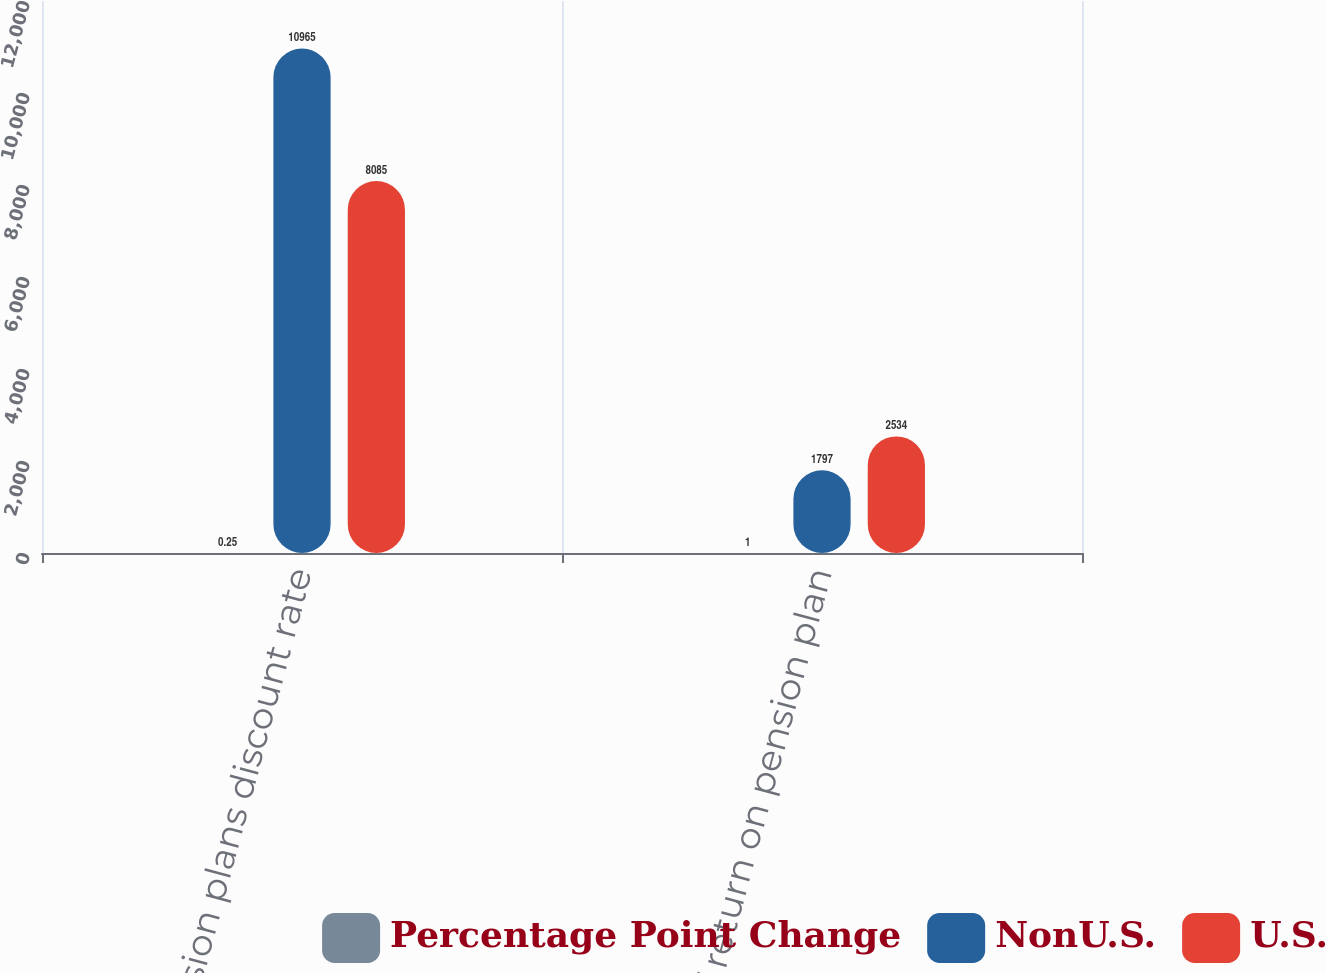<chart> <loc_0><loc_0><loc_500><loc_500><stacked_bar_chart><ecel><fcel>Pension plans discount rate<fcel>Rate of return on pension plan<nl><fcel>Percentage Point Change<fcel>0.25<fcel>1<nl><fcel>NonU.S.<fcel>10965<fcel>1797<nl><fcel>U.S.<fcel>8085<fcel>2534<nl></chart> 